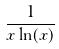<formula> <loc_0><loc_0><loc_500><loc_500>\frac { 1 } { x \ln ( x ) }</formula> 